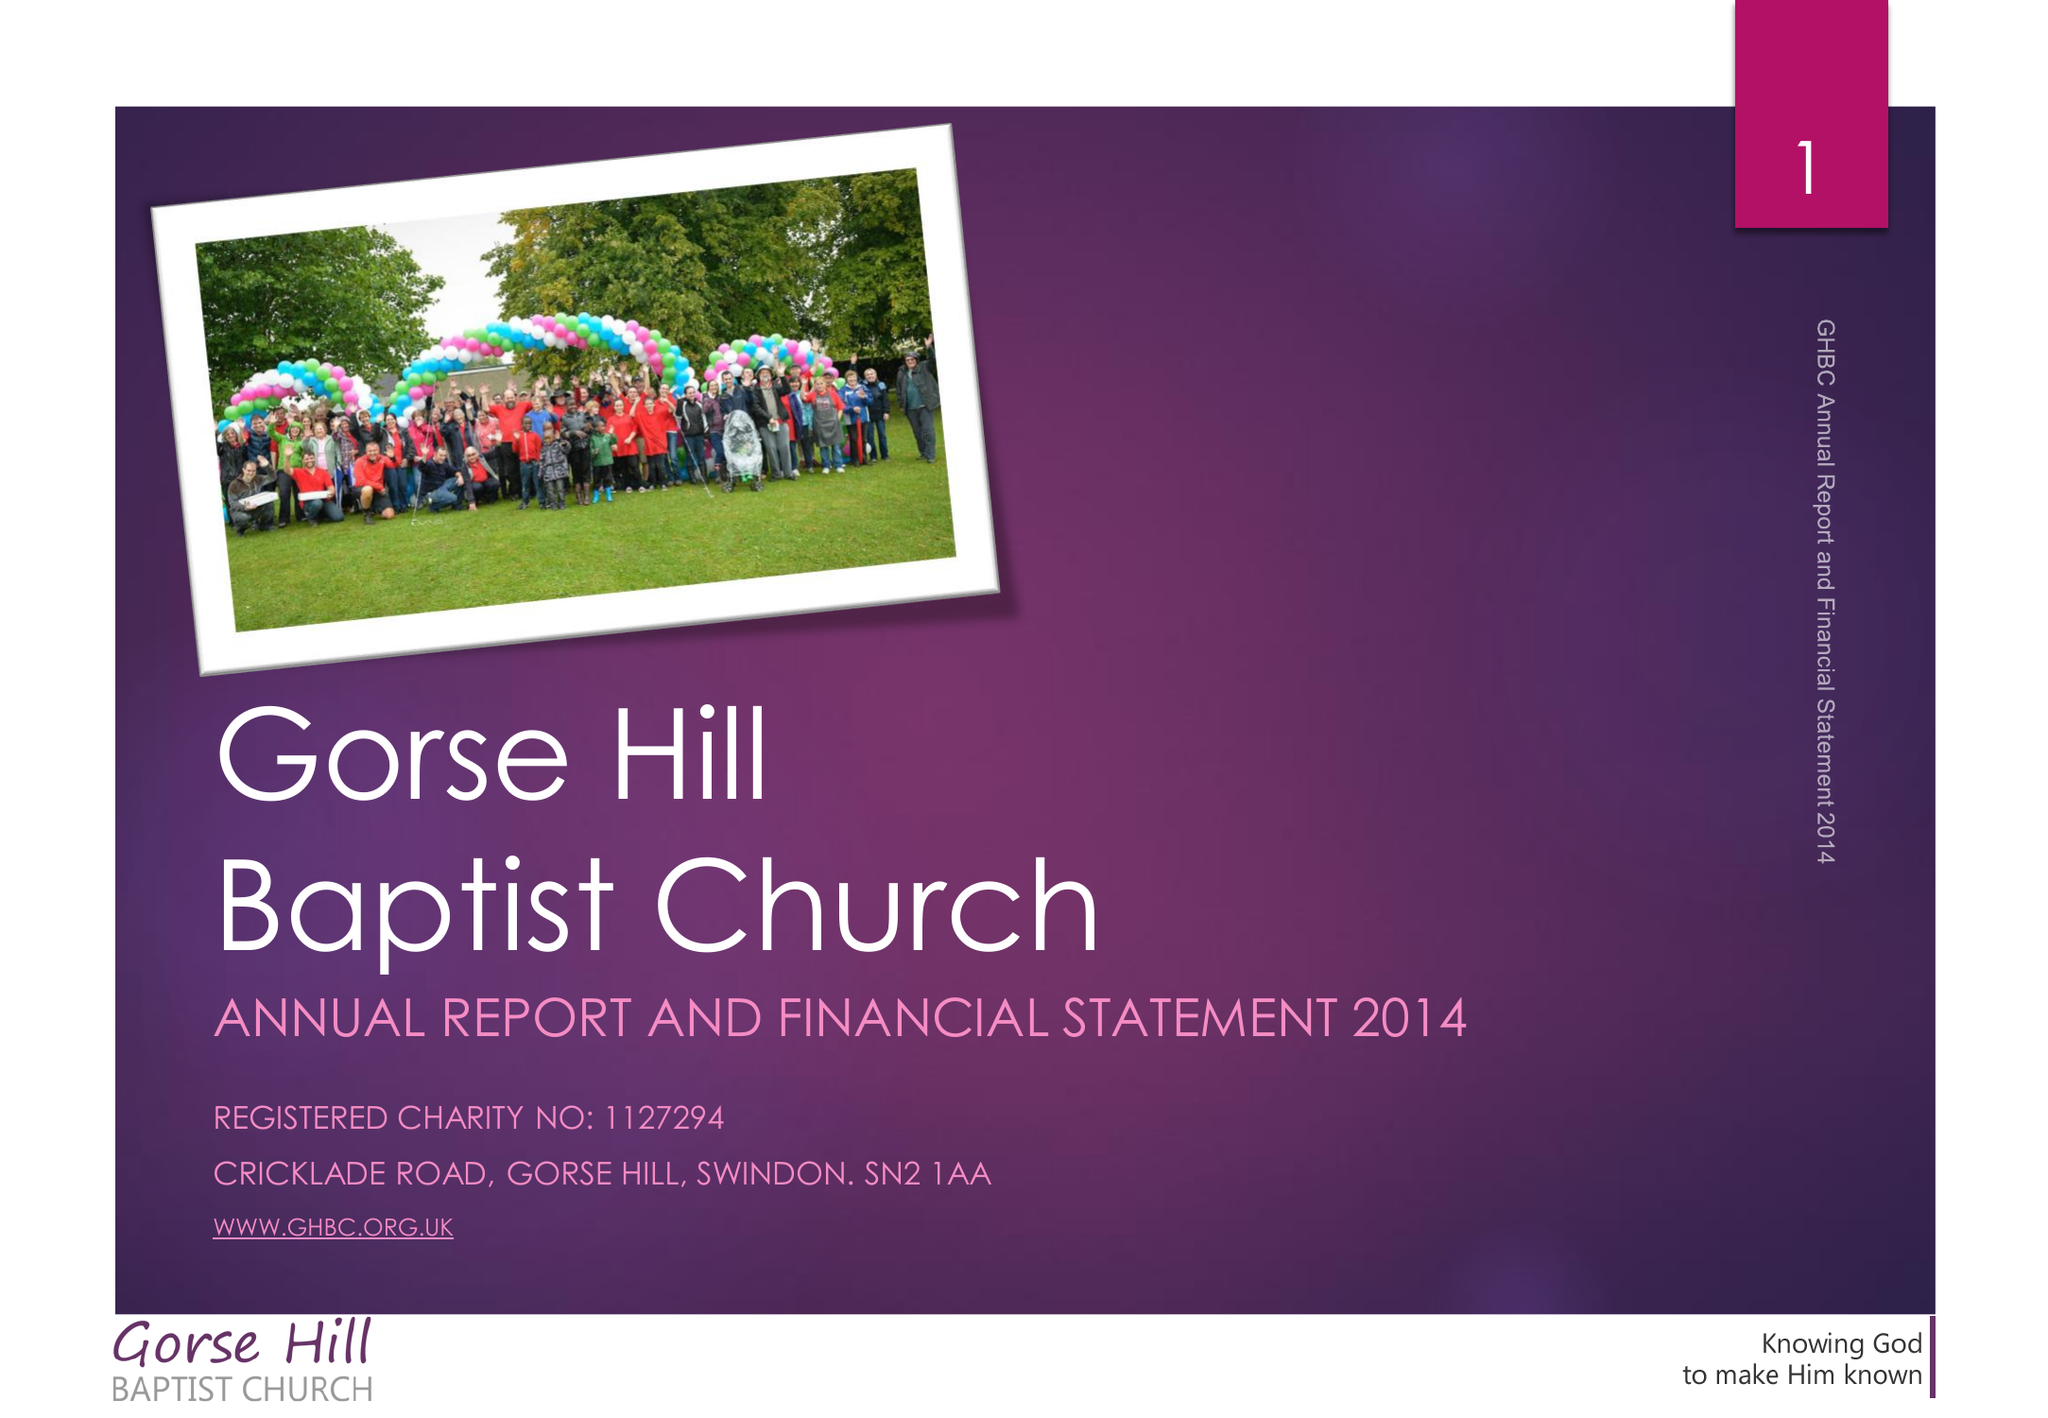What is the value for the income_annually_in_british_pounds?
Answer the question using a single word or phrase. 170340.00 